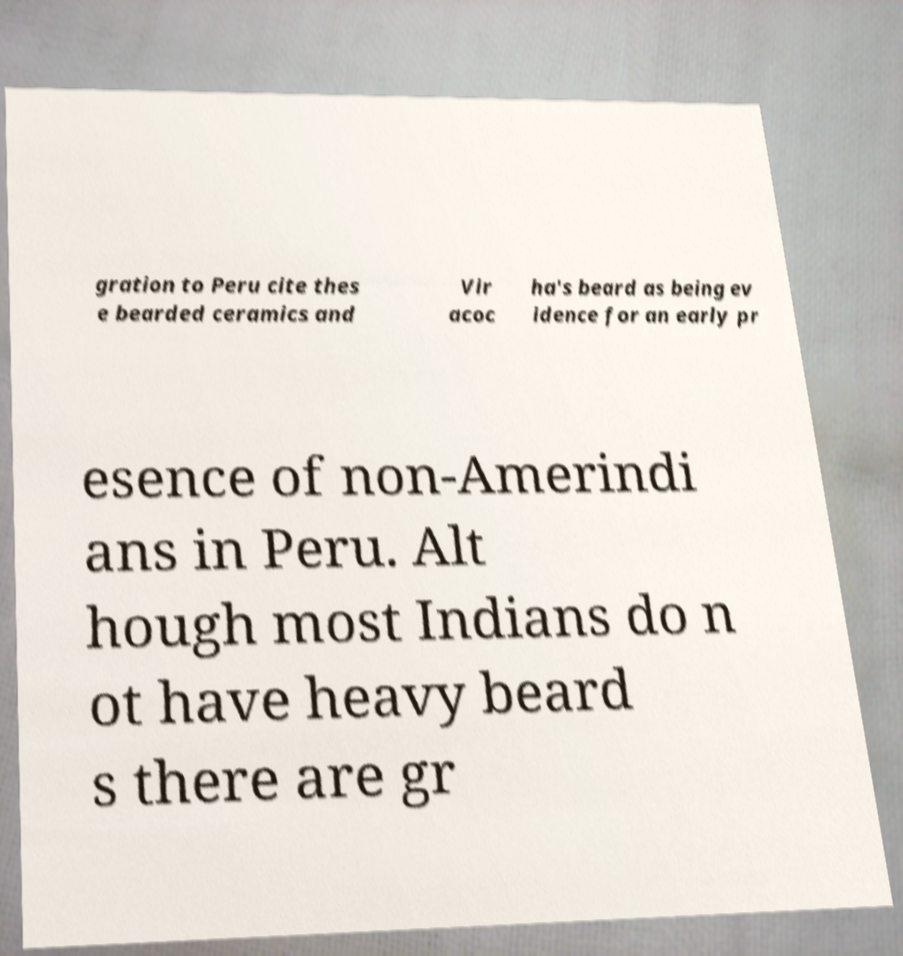Can you accurately transcribe the text from the provided image for me? gration to Peru cite thes e bearded ceramics and Vir acoc ha's beard as being ev idence for an early pr esence of non-Amerindi ans in Peru. Alt hough most Indians do n ot have heavy beard s there are gr 